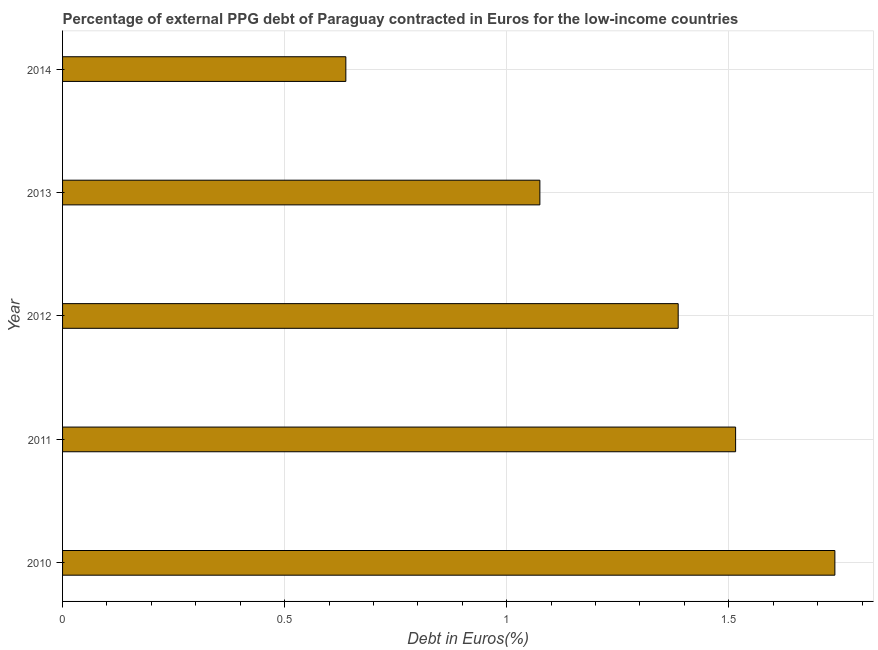Does the graph contain any zero values?
Provide a short and direct response. No. Does the graph contain grids?
Provide a succinct answer. Yes. What is the title of the graph?
Provide a succinct answer. Percentage of external PPG debt of Paraguay contracted in Euros for the low-income countries. What is the label or title of the X-axis?
Give a very brief answer. Debt in Euros(%). What is the currency composition of ppg debt in 2013?
Ensure brevity in your answer.  1.07. Across all years, what is the maximum currency composition of ppg debt?
Offer a terse response. 1.74. Across all years, what is the minimum currency composition of ppg debt?
Your answer should be very brief. 0.64. In which year was the currency composition of ppg debt minimum?
Ensure brevity in your answer.  2014. What is the sum of the currency composition of ppg debt?
Provide a succinct answer. 6.35. What is the difference between the currency composition of ppg debt in 2010 and 2012?
Provide a short and direct response. 0.35. What is the average currency composition of ppg debt per year?
Provide a succinct answer. 1.27. What is the median currency composition of ppg debt?
Give a very brief answer. 1.39. In how many years, is the currency composition of ppg debt greater than 1.1 %?
Give a very brief answer. 3. What is the ratio of the currency composition of ppg debt in 2012 to that in 2013?
Provide a succinct answer. 1.29. Is the difference between the currency composition of ppg debt in 2011 and 2013 greater than the difference between any two years?
Your response must be concise. No. What is the difference between the highest and the second highest currency composition of ppg debt?
Give a very brief answer. 0.22. Are the values on the major ticks of X-axis written in scientific E-notation?
Offer a terse response. No. What is the Debt in Euros(%) of 2010?
Provide a short and direct response. 1.74. What is the Debt in Euros(%) of 2011?
Your answer should be very brief. 1.52. What is the Debt in Euros(%) of 2012?
Ensure brevity in your answer.  1.39. What is the Debt in Euros(%) in 2013?
Make the answer very short. 1.07. What is the Debt in Euros(%) of 2014?
Ensure brevity in your answer.  0.64. What is the difference between the Debt in Euros(%) in 2010 and 2011?
Provide a succinct answer. 0.22. What is the difference between the Debt in Euros(%) in 2010 and 2012?
Your answer should be very brief. 0.35. What is the difference between the Debt in Euros(%) in 2010 and 2013?
Offer a very short reply. 0.66. What is the difference between the Debt in Euros(%) in 2010 and 2014?
Make the answer very short. 1.1. What is the difference between the Debt in Euros(%) in 2011 and 2012?
Your answer should be very brief. 0.13. What is the difference between the Debt in Euros(%) in 2011 and 2013?
Give a very brief answer. 0.44. What is the difference between the Debt in Euros(%) in 2011 and 2014?
Keep it short and to the point. 0.88. What is the difference between the Debt in Euros(%) in 2012 and 2013?
Ensure brevity in your answer.  0.31. What is the difference between the Debt in Euros(%) in 2012 and 2014?
Offer a terse response. 0.75. What is the difference between the Debt in Euros(%) in 2013 and 2014?
Provide a succinct answer. 0.44. What is the ratio of the Debt in Euros(%) in 2010 to that in 2011?
Your response must be concise. 1.15. What is the ratio of the Debt in Euros(%) in 2010 to that in 2012?
Make the answer very short. 1.25. What is the ratio of the Debt in Euros(%) in 2010 to that in 2013?
Keep it short and to the point. 1.62. What is the ratio of the Debt in Euros(%) in 2010 to that in 2014?
Your answer should be very brief. 2.73. What is the ratio of the Debt in Euros(%) in 2011 to that in 2012?
Offer a terse response. 1.09. What is the ratio of the Debt in Euros(%) in 2011 to that in 2013?
Ensure brevity in your answer.  1.41. What is the ratio of the Debt in Euros(%) in 2011 to that in 2014?
Provide a short and direct response. 2.38. What is the ratio of the Debt in Euros(%) in 2012 to that in 2013?
Give a very brief answer. 1.29. What is the ratio of the Debt in Euros(%) in 2012 to that in 2014?
Provide a short and direct response. 2.17. What is the ratio of the Debt in Euros(%) in 2013 to that in 2014?
Provide a succinct answer. 1.69. 